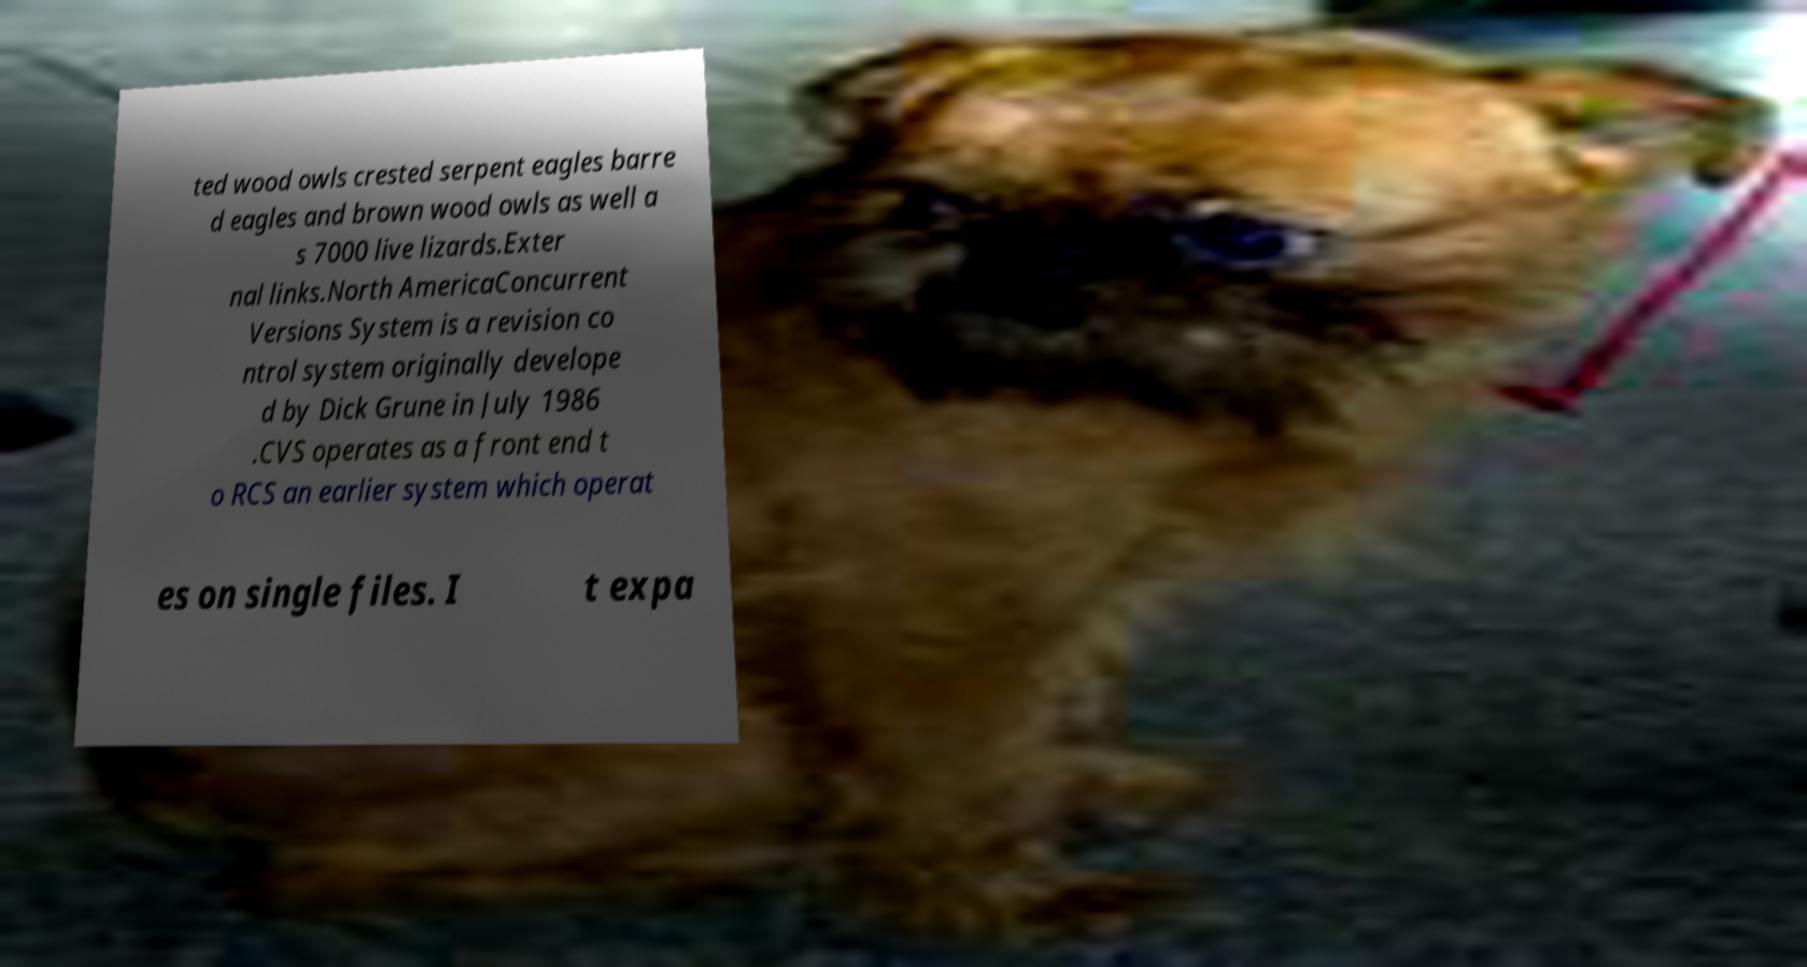There's text embedded in this image that I need extracted. Can you transcribe it verbatim? ted wood owls crested serpent eagles barre d eagles and brown wood owls as well a s 7000 live lizards.Exter nal links.North AmericaConcurrent Versions System is a revision co ntrol system originally develope d by Dick Grune in July 1986 .CVS operates as a front end t o RCS an earlier system which operat es on single files. I t expa 